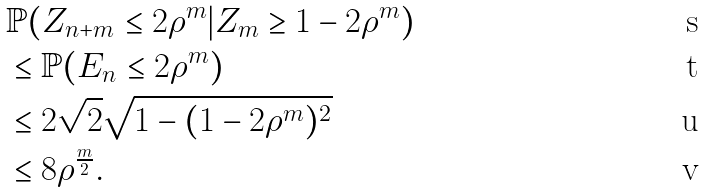Convert formula to latex. <formula><loc_0><loc_0><loc_500><loc_500>& \mathbb { P } ( Z _ { n + m } \leq 2 { \rho } ^ { m } | Z _ { m } \geq 1 - 2 { \rho } ^ { m } ) \\ & \leq \mathbb { P } ( E _ { n } \leq 2 { \rho } ^ { m } ) \\ & \leq 2 \sqrt { 2 } \sqrt { 1 - ( 1 - 2 { \rho } ^ { m } ) ^ { 2 } } \\ & \leq 8 { \rho } ^ { \frac { m } { 2 } } .</formula> 